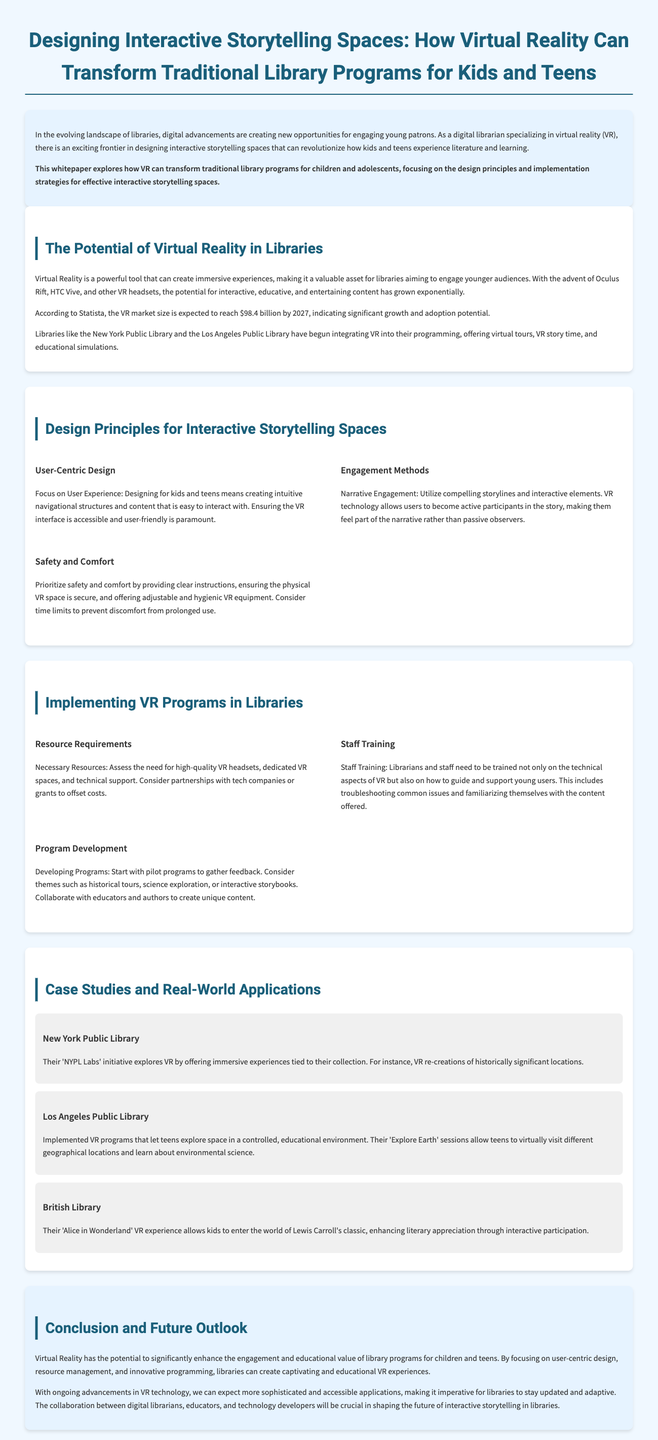What is the title of the whitepaper? The title is explicitly stated at the top of the document.
Answer: Designing Interactive Storytelling Spaces: How Virtual Reality Can Transform Traditional Library Programs for Kids and Teens What is the expected VR market size by 2027? The document provides a statistic about the growth of the VR market, mentioning a specific figure.
Answer: $98.4 billion Which libraries have begun integrating VR into their programming? The document lists specific libraries that have implemented VR.
Answer: New York Public Library and Los Angeles Public Library What is one of the design principles mentioned for interactive storytelling spaces? The document includes various design principles for the spaces meant for kids and teens.
Answer: User-Centric Design What training is necessary for library staff when implementing VR? The document emphasizes the need for training staff on certain aspects of VR usage in libraries.
Answer: Technical aspects and guiding young users Which case study features VR re-creations of historically significant locations? The section on case studies provides specific examples of libraries engaging in VR experiences.
Answer: New York Public Library What safety consideration is suggested for VR use in libraries? The document discusses important aspects of safety and comfort in VR implementation.
Answer: Clear instructions What theme is suggested for developing VR programs? The document recommends certain themes for library programs when utilizing VR technology.
Answer: Historical tours 